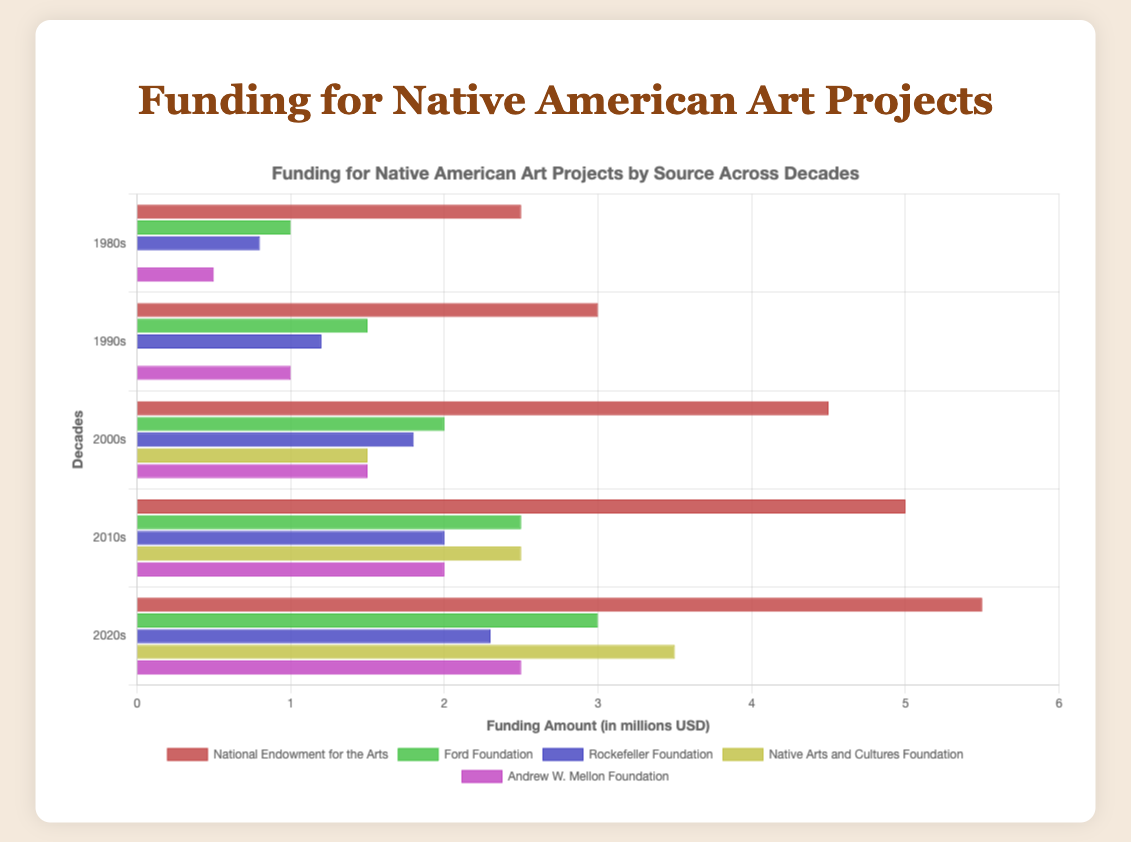What funding source has the highest funding amount in the 2020s? Look at the 2020s bar and identify the longest bar, which corresponds to the highest funding amount.
Answer: National Endowment for the Arts Which decade saw the largest increase in funding for the Ford Foundation compared to the previous decade? Compare the funding amounts for the Ford Foundation between each consecutive decade to identify which decade had the largest increase. 1990s: 1.5 - 1.0 = 0.5, 2000s: 2.0 - 1.5 = 0.5, 2010s: 2.5 - 2.0 = 0.5, 2020s: 3.0 - 2.5 = 0.5. Thus, all increases are equal, so technically every decade saw the same increase.
Answer: Equal increase in each decade What was the total funding amount provided by the National Endowment for the Arts over all decades? Add the funding amounts for the National Endowment for the Arts over each decade: 2.5 + 3.0 + 4.5 + 5.0 + 5.5.
Answer: 20.5 million USD Which funding source shows the most consistent increase over the decades, and what evidence supports this? Identify the funding source whose funding data increases steadily without any drops or irregularities. Verify the consistency: National Endowment for the Arts: 2.5, 3.0, 4.5, 5.0, 5.5 (consistent increase); Ford Foundation: 1.0, 1.5, 2.0, 2.5, 3.0 (consistent increase); Rockefeller Foundation: 0.8, 1.2, 1.8, 2.0, 2.3 (consistent increase); Native Arts and Cultures Foundation: 0, 0, 1.5, 2.5, 3.5 (not consistent, starts from 0); Andrew W. Mellon Foundation: 0.5, 1.0, 1.5, 2.0, 2.5 (consistent increase).
Answer: National Endowment for the Arts, Ford Foundation, Rockefeller Foundation, and Andrew W. Mellon Foundation In which decade did the Native Arts and Cultures Foundation start receiving funding, and what was the amount in that decade? Look at the data for Native Arts and Cultures Foundation and identify the first decade with non-zero funding.
Answer: 2000s, 1.5 million USD What is the average funding amount received by the Rockefeller Foundation across all decades? Add the funding amounts received by the Rockefeller Foundation and divide by the number of decades. (0.8 + 1.2 + 1.8 + 2.0 + 2.3) / 5.
Answer: 1.62 million USD Compare the funding received by the National Endowment for the Arts and the Ford Foundation in the 2010s. Which was higher and by how much? Look at the funding amounts for both organizations in the 2010s: National Endowment for the Arts (5.0) and Ford Foundation (2.5). Calculate the difference: 5.0 - 2.5.
Answer: National Endowment for the Arts by 2.5 million USD Which decade displayed the smallest total funding for Native American art projects from all sources combined, and what was the total? Add the funding from all sources in each decade, and determine the smallest value. 1980s: 2.5 + 1.0 + 0.8 + 0 + 0.5 = 4.8, 1990s: 3.0 + 1.5 + 1.2 + 0 + 1.0 = 6.7, 2000s: 4.5 + 2.0 + 1.8 + 1.5 + 1.5 = 11.3, 2010s: 5.0 + 2.5 + 2.0 + 2.5 + 2.0 = 14, 2020s: 5.5 + 3.0 + 2.3 + 3.5 + 2.5 = 16.8.
Answer: 1980s, 4.8 million USD Does the Andrew W. Mellon Foundation have any decade where its funding did not increase from the previous decade? If so, which one(s)? Compare the funding amounts of the Andrew W. Mellon Foundation between each consecutive decade. 1980s: 0.5, 1990s: 1.0, 2000s: 1.5, 2010s: 2.0, 2020s: 2.5. Each decade shows an increase.
Answer: No 